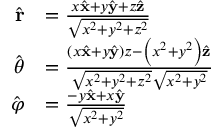<formula> <loc_0><loc_0><loc_500><loc_500>{ \begin{array} { r l } { { \hat { r } } } & { = { \frac { x { \hat { x } } + y { \hat { y } } + z { \hat { z } } } { \sqrt { x ^ { 2 } + y ^ { 2 } + z ^ { 2 } } } } } \\ { { \hat { \theta } } } & { = { \frac { \left ( x { \hat { x } } + y { \hat { y } } \right ) z - \left ( x ^ { 2 } + y ^ { 2 } \right ) { \hat { z } } } { { \sqrt { x ^ { 2 } + y ^ { 2 } + z ^ { 2 } } } { \sqrt { x ^ { 2 } + y ^ { 2 } } } } } } \\ { { \hat { \varphi } } } & { = { \frac { - y { \hat { x } } + x { \hat { y } } } { \sqrt { x ^ { 2 } + y ^ { 2 } } } } } \end{array} }</formula> 